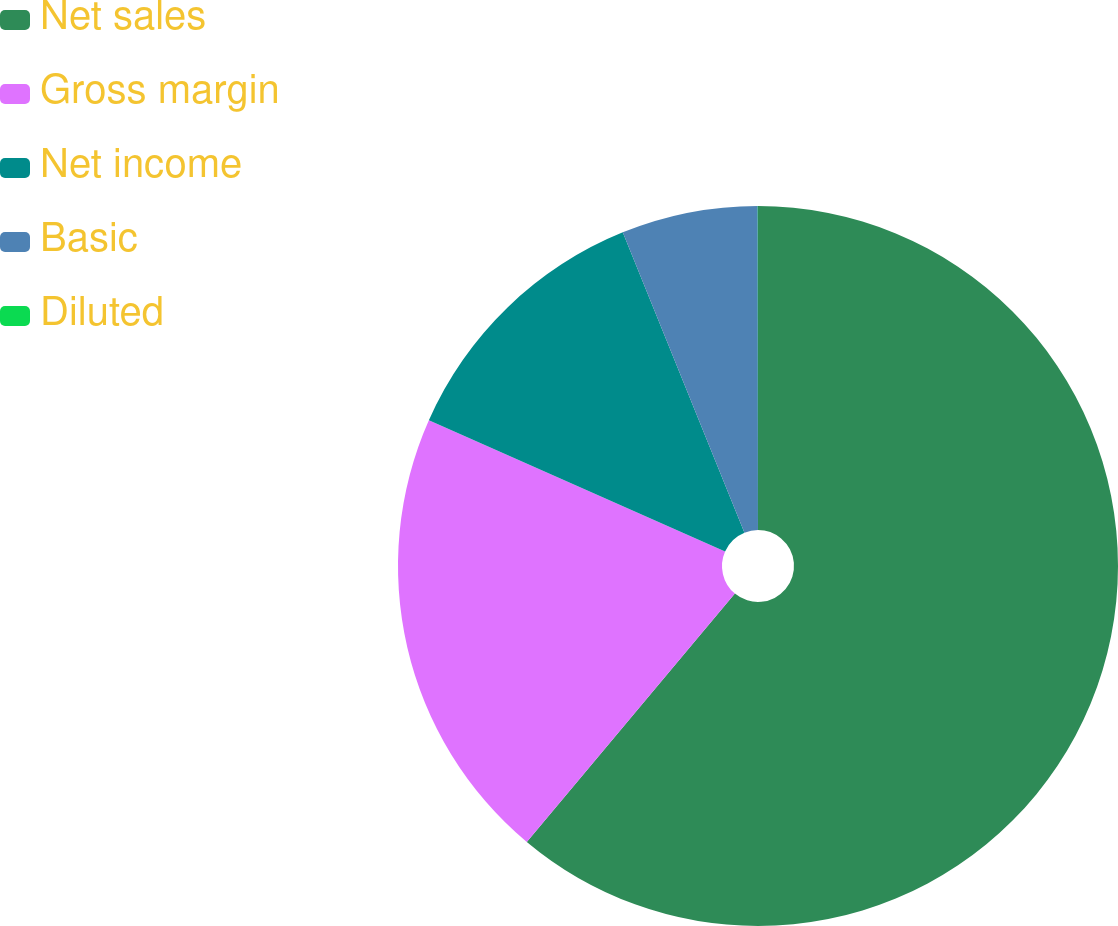Convert chart to OTSL. <chart><loc_0><loc_0><loc_500><loc_500><pie_chart><fcel>Net sales<fcel>Gross margin<fcel>Net income<fcel>Basic<fcel>Diluted<nl><fcel>61.1%<fcel>20.54%<fcel>12.23%<fcel>6.12%<fcel>0.01%<nl></chart> 